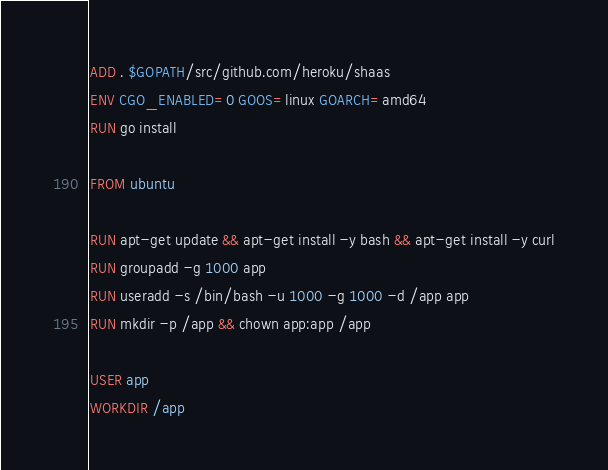<code> <loc_0><loc_0><loc_500><loc_500><_Dockerfile_>ADD . $GOPATH/src/github.com/heroku/shaas
ENV CGO_ENABLED=0 GOOS=linux GOARCH=amd64
RUN go install

FROM ubuntu

RUN apt-get update && apt-get install -y bash && apt-get install -y curl
RUN groupadd -g 1000 app
RUN useradd -s /bin/bash -u 1000 -g 1000 -d /app app
RUN mkdir -p /app && chown app:app /app

USER app
WORKDIR /app
</code> 